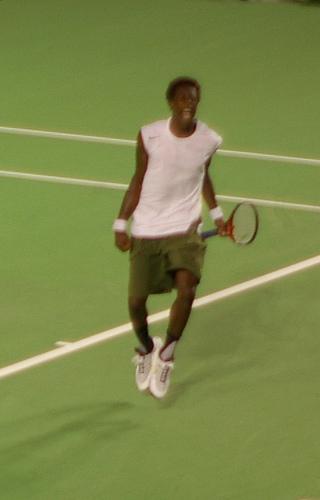How many courts can be seen?
Quick response, please. 1. What two words describe the shirt the player is wearing?
Give a very brief answer. Tank top. Are the man's feet on the ground?
Concise answer only. No. Are sweat bands on both wrists?
Give a very brief answer. Yes. What color is the court?
Be succinct. Green. 